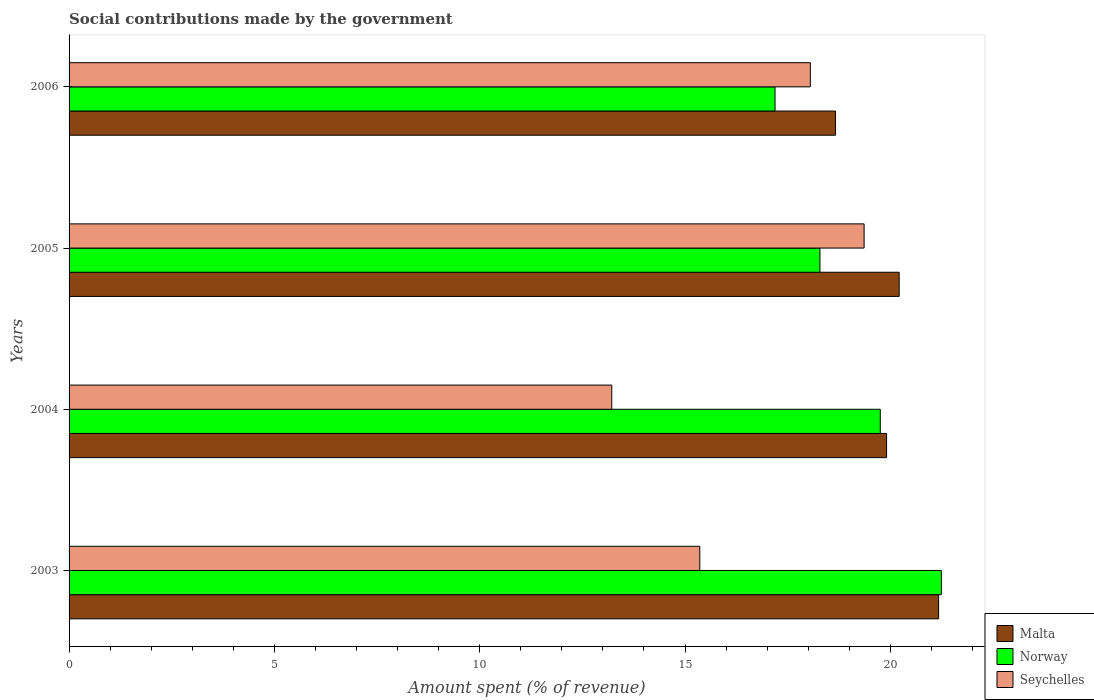How many groups of bars are there?
Your response must be concise. 4. Are the number of bars per tick equal to the number of legend labels?
Offer a very short reply. Yes. Are the number of bars on each tick of the Y-axis equal?
Your answer should be very brief. Yes. How many bars are there on the 3rd tick from the top?
Your answer should be very brief. 3. What is the label of the 3rd group of bars from the top?
Ensure brevity in your answer.  2004. What is the amount spent (in %) on social contributions in Malta in 2003?
Your answer should be compact. 21.18. Across all years, what is the maximum amount spent (in %) on social contributions in Malta?
Your answer should be very brief. 21.18. Across all years, what is the minimum amount spent (in %) on social contributions in Malta?
Your response must be concise. 18.67. What is the total amount spent (in %) on social contributions in Norway in the graph?
Your answer should be very brief. 76.48. What is the difference between the amount spent (in %) on social contributions in Seychelles in 2005 and that in 2006?
Ensure brevity in your answer.  1.31. What is the difference between the amount spent (in %) on social contributions in Norway in 2004 and the amount spent (in %) on social contributions in Malta in 2005?
Offer a terse response. -0.46. What is the average amount spent (in %) on social contributions in Norway per year?
Your answer should be compact. 19.12. In the year 2004, what is the difference between the amount spent (in %) on social contributions in Norway and amount spent (in %) on social contributions in Malta?
Make the answer very short. -0.15. In how many years, is the amount spent (in %) on social contributions in Seychelles greater than 5 %?
Your answer should be compact. 4. What is the ratio of the amount spent (in %) on social contributions in Malta in 2003 to that in 2005?
Provide a succinct answer. 1.05. What is the difference between the highest and the second highest amount spent (in %) on social contributions in Seychelles?
Ensure brevity in your answer.  1.31. What is the difference between the highest and the lowest amount spent (in %) on social contributions in Norway?
Provide a succinct answer. 4.05. In how many years, is the amount spent (in %) on social contributions in Malta greater than the average amount spent (in %) on social contributions in Malta taken over all years?
Give a very brief answer. 2. What does the 3rd bar from the top in 2004 represents?
Your response must be concise. Malta. What does the 1st bar from the bottom in 2004 represents?
Provide a short and direct response. Malta. What is the difference between two consecutive major ticks on the X-axis?
Your answer should be very brief. 5. Are the values on the major ticks of X-axis written in scientific E-notation?
Give a very brief answer. No. Does the graph contain any zero values?
Your answer should be very brief. No. Does the graph contain grids?
Make the answer very short. No. What is the title of the graph?
Your answer should be compact. Social contributions made by the government. What is the label or title of the X-axis?
Provide a short and direct response. Amount spent (% of revenue). What is the label or title of the Y-axis?
Your response must be concise. Years. What is the Amount spent (% of revenue) of Malta in 2003?
Keep it short and to the point. 21.18. What is the Amount spent (% of revenue) in Norway in 2003?
Offer a very short reply. 21.24. What is the Amount spent (% of revenue) of Seychelles in 2003?
Provide a short and direct response. 15.36. What is the Amount spent (% of revenue) in Malta in 2004?
Ensure brevity in your answer.  19.91. What is the Amount spent (% of revenue) of Norway in 2004?
Your answer should be very brief. 19.76. What is the Amount spent (% of revenue) in Seychelles in 2004?
Your answer should be very brief. 13.22. What is the Amount spent (% of revenue) of Malta in 2005?
Give a very brief answer. 20.22. What is the Amount spent (% of revenue) in Norway in 2005?
Give a very brief answer. 18.29. What is the Amount spent (% of revenue) of Seychelles in 2005?
Make the answer very short. 19.36. What is the Amount spent (% of revenue) in Malta in 2006?
Offer a terse response. 18.67. What is the Amount spent (% of revenue) of Norway in 2006?
Give a very brief answer. 17.19. What is the Amount spent (% of revenue) in Seychelles in 2006?
Your answer should be compact. 18.05. Across all years, what is the maximum Amount spent (% of revenue) in Malta?
Your answer should be very brief. 21.18. Across all years, what is the maximum Amount spent (% of revenue) in Norway?
Make the answer very short. 21.24. Across all years, what is the maximum Amount spent (% of revenue) in Seychelles?
Your answer should be very brief. 19.36. Across all years, what is the minimum Amount spent (% of revenue) in Malta?
Keep it short and to the point. 18.67. Across all years, what is the minimum Amount spent (% of revenue) of Norway?
Your answer should be very brief. 17.19. Across all years, what is the minimum Amount spent (% of revenue) of Seychelles?
Make the answer very short. 13.22. What is the total Amount spent (% of revenue) in Malta in the graph?
Offer a very short reply. 79.97. What is the total Amount spent (% of revenue) of Norway in the graph?
Give a very brief answer. 76.48. What is the total Amount spent (% of revenue) in Seychelles in the graph?
Keep it short and to the point. 65.99. What is the difference between the Amount spent (% of revenue) of Malta in 2003 and that in 2004?
Your answer should be compact. 1.27. What is the difference between the Amount spent (% of revenue) of Norway in 2003 and that in 2004?
Your response must be concise. 1.49. What is the difference between the Amount spent (% of revenue) of Seychelles in 2003 and that in 2004?
Your answer should be compact. 2.14. What is the difference between the Amount spent (% of revenue) of Malta in 2003 and that in 2005?
Your answer should be compact. 0.96. What is the difference between the Amount spent (% of revenue) of Norway in 2003 and that in 2005?
Offer a terse response. 2.96. What is the difference between the Amount spent (% of revenue) of Seychelles in 2003 and that in 2005?
Provide a succinct answer. -4. What is the difference between the Amount spent (% of revenue) in Malta in 2003 and that in 2006?
Provide a short and direct response. 2.51. What is the difference between the Amount spent (% of revenue) of Norway in 2003 and that in 2006?
Provide a short and direct response. 4.05. What is the difference between the Amount spent (% of revenue) in Seychelles in 2003 and that in 2006?
Offer a terse response. -2.69. What is the difference between the Amount spent (% of revenue) in Malta in 2004 and that in 2005?
Offer a terse response. -0.31. What is the difference between the Amount spent (% of revenue) of Norway in 2004 and that in 2005?
Provide a short and direct response. 1.47. What is the difference between the Amount spent (% of revenue) of Seychelles in 2004 and that in 2005?
Give a very brief answer. -6.15. What is the difference between the Amount spent (% of revenue) in Malta in 2004 and that in 2006?
Ensure brevity in your answer.  1.24. What is the difference between the Amount spent (% of revenue) in Norway in 2004 and that in 2006?
Keep it short and to the point. 2.56. What is the difference between the Amount spent (% of revenue) in Seychelles in 2004 and that in 2006?
Offer a terse response. -4.84. What is the difference between the Amount spent (% of revenue) of Malta in 2005 and that in 2006?
Offer a terse response. 1.55. What is the difference between the Amount spent (% of revenue) in Norway in 2005 and that in 2006?
Ensure brevity in your answer.  1.09. What is the difference between the Amount spent (% of revenue) of Seychelles in 2005 and that in 2006?
Offer a very short reply. 1.31. What is the difference between the Amount spent (% of revenue) of Malta in 2003 and the Amount spent (% of revenue) of Norway in 2004?
Make the answer very short. 1.42. What is the difference between the Amount spent (% of revenue) in Malta in 2003 and the Amount spent (% of revenue) in Seychelles in 2004?
Your response must be concise. 7.96. What is the difference between the Amount spent (% of revenue) of Norway in 2003 and the Amount spent (% of revenue) of Seychelles in 2004?
Provide a succinct answer. 8.03. What is the difference between the Amount spent (% of revenue) in Malta in 2003 and the Amount spent (% of revenue) in Norway in 2005?
Provide a short and direct response. 2.89. What is the difference between the Amount spent (% of revenue) of Malta in 2003 and the Amount spent (% of revenue) of Seychelles in 2005?
Ensure brevity in your answer.  1.81. What is the difference between the Amount spent (% of revenue) of Norway in 2003 and the Amount spent (% of revenue) of Seychelles in 2005?
Ensure brevity in your answer.  1.88. What is the difference between the Amount spent (% of revenue) in Malta in 2003 and the Amount spent (% of revenue) in Norway in 2006?
Provide a succinct answer. 3.98. What is the difference between the Amount spent (% of revenue) in Malta in 2003 and the Amount spent (% of revenue) in Seychelles in 2006?
Keep it short and to the point. 3.12. What is the difference between the Amount spent (% of revenue) in Norway in 2003 and the Amount spent (% of revenue) in Seychelles in 2006?
Make the answer very short. 3.19. What is the difference between the Amount spent (% of revenue) of Malta in 2004 and the Amount spent (% of revenue) of Norway in 2005?
Make the answer very short. 1.62. What is the difference between the Amount spent (% of revenue) of Malta in 2004 and the Amount spent (% of revenue) of Seychelles in 2005?
Provide a short and direct response. 0.55. What is the difference between the Amount spent (% of revenue) of Norway in 2004 and the Amount spent (% of revenue) of Seychelles in 2005?
Ensure brevity in your answer.  0.39. What is the difference between the Amount spent (% of revenue) of Malta in 2004 and the Amount spent (% of revenue) of Norway in 2006?
Give a very brief answer. 2.72. What is the difference between the Amount spent (% of revenue) in Malta in 2004 and the Amount spent (% of revenue) in Seychelles in 2006?
Give a very brief answer. 1.86. What is the difference between the Amount spent (% of revenue) of Norway in 2004 and the Amount spent (% of revenue) of Seychelles in 2006?
Keep it short and to the point. 1.7. What is the difference between the Amount spent (% of revenue) of Malta in 2005 and the Amount spent (% of revenue) of Norway in 2006?
Your response must be concise. 3.02. What is the difference between the Amount spent (% of revenue) of Malta in 2005 and the Amount spent (% of revenue) of Seychelles in 2006?
Your answer should be very brief. 2.16. What is the difference between the Amount spent (% of revenue) of Norway in 2005 and the Amount spent (% of revenue) of Seychelles in 2006?
Make the answer very short. 0.23. What is the average Amount spent (% of revenue) in Malta per year?
Ensure brevity in your answer.  19.99. What is the average Amount spent (% of revenue) of Norway per year?
Provide a succinct answer. 19.12. What is the average Amount spent (% of revenue) in Seychelles per year?
Your answer should be compact. 16.5. In the year 2003, what is the difference between the Amount spent (% of revenue) in Malta and Amount spent (% of revenue) in Norway?
Your response must be concise. -0.07. In the year 2003, what is the difference between the Amount spent (% of revenue) of Malta and Amount spent (% of revenue) of Seychelles?
Your answer should be very brief. 5.82. In the year 2003, what is the difference between the Amount spent (% of revenue) of Norway and Amount spent (% of revenue) of Seychelles?
Your answer should be compact. 5.88. In the year 2004, what is the difference between the Amount spent (% of revenue) in Malta and Amount spent (% of revenue) in Norway?
Ensure brevity in your answer.  0.15. In the year 2004, what is the difference between the Amount spent (% of revenue) in Malta and Amount spent (% of revenue) in Seychelles?
Keep it short and to the point. 6.69. In the year 2004, what is the difference between the Amount spent (% of revenue) in Norway and Amount spent (% of revenue) in Seychelles?
Your answer should be compact. 6.54. In the year 2005, what is the difference between the Amount spent (% of revenue) in Malta and Amount spent (% of revenue) in Norway?
Your answer should be compact. 1.93. In the year 2005, what is the difference between the Amount spent (% of revenue) in Malta and Amount spent (% of revenue) in Seychelles?
Ensure brevity in your answer.  0.85. In the year 2005, what is the difference between the Amount spent (% of revenue) of Norway and Amount spent (% of revenue) of Seychelles?
Your answer should be compact. -1.08. In the year 2006, what is the difference between the Amount spent (% of revenue) in Malta and Amount spent (% of revenue) in Norway?
Offer a terse response. 1.47. In the year 2006, what is the difference between the Amount spent (% of revenue) of Malta and Amount spent (% of revenue) of Seychelles?
Give a very brief answer. 0.61. In the year 2006, what is the difference between the Amount spent (% of revenue) of Norway and Amount spent (% of revenue) of Seychelles?
Your answer should be compact. -0.86. What is the ratio of the Amount spent (% of revenue) in Malta in 2003 to that in 2004?
Offer a terse response. 1.06. What is the ratio of the Amount spent (% of revenue) of Norway in 2003 to that in 2004?
Provide a succinct answer. 1.08. What is the ratio of the Amount spent (% of revenue) of Seychelles in 2003 to that in 2004?
Offer a very short reply. 1.16. What is the ratio of the Amount spent (% of revenue) of Malta in 2003 to that in 2005?
Ensure brevity in your answer.  1.05. What is the ratio of the Amount spent (% of revenue) in Norway in 2003 to that in 2005?
Offer a terse response. 1.16. What is the ratio of the Amount spent (% of revenue) in Seychelles in 2003 to that in 2005?
Provide a succinct answer. 0.79. What is the ratio of the Amount spent (% of revenue) of Malta in 2003 to that in 2006?
Make the answer very short. 1.13. What is the ratio of the Amount spent (% of revenue) in Norway in 2003 to that in 2006?
Offer a very short reply. 1.24. What is the ratio of the Amount spent (% of revenue) in Seychelles in 2003 to that in 2006?
Offer a terse response. 0.85. What is the ratio of the Amount spent (% of revenue) in Malta in 2004 to that in 2005?
Give a very brief answer. 0.98. What is the ratio of the Amount spent (% of revenue) in Norway in 2004 to that in 2005?
Your answer should be compact. 1.08. What is the ratio of the Amount spent (% of revenue) in Seychelles in 2004 to that in 2005?
Make the answer very short. 0.68. What is the ratio of the Amount spent (% of revenue) of Malta in 2004 to that in 2006?
Your answer should be very brief. 1.07. What is the ratio of the Amount spent (% of revenue) of Norway in 2004 to that in 2006?
Your response must be concise. 1.15. What is the ratio of the Amount spent (% of revenue) in Seychelles in 2004 to that in 2006?
Make the answer very short. 0.73. What is the ratio of the Amount spent (% of revenue) of Malta in 2005 to that in 2006?
Make the answer very short. 1.08. What is the ratio of the Amount spent (% of revenue) in Norway in 2005 to that in 2006?
Make the answer very short. 1.06. What is the ratio of the Amount spent (% of revenue) in Seychelles in 2005 to that in 2006?
Offer a terse response. 1.07. What is the difference between the highest and the second highest Amount spent (% of revenue) of Malta?
Provide a short and direct response. 0.96. What is the difference between the highest and the second highest Amount spent (% of revenue) of Norway?
Your response must be concise. 1.49. What is the difference between the highest and the second highest Amount spent (% of revenue) in Seychelles?
Make the answer very short. 1.31. What is the difference between the highest and the lowest Amount spent (% of revenue) of Malta?
Your answer should be very brief. 2.51. What is the difference between the highest and the lowest Amount spent (% of revenue) in Norway?
Your answer should be very brief. 4.05. What is the difference between the highest and the lowest Amount spent (% of revenue) in Seychelles?
Provide a succinct answer. 6.15. 